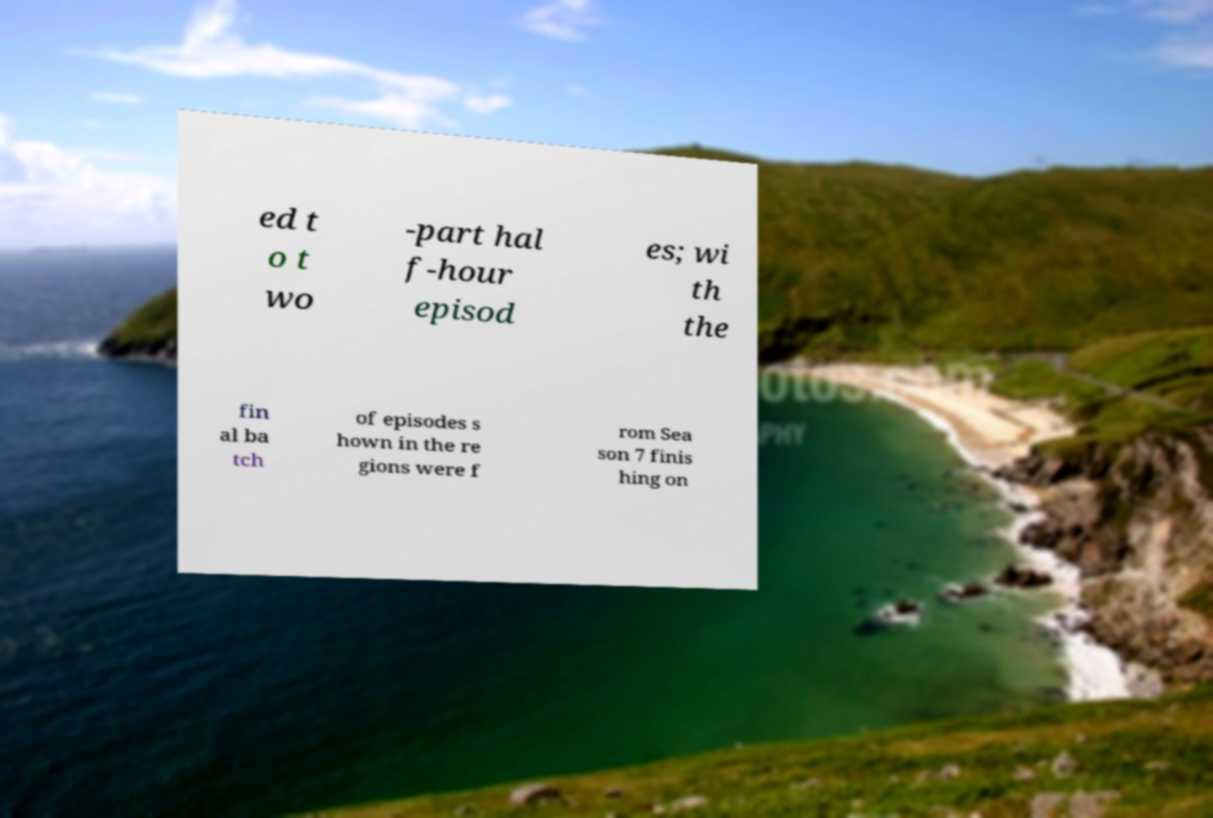There's text embedded in this image that I need extracted. Can you transcribe it verbatim? ed t o t wo -part hal f-hour episod es; wi th the fin al ba tch of episodes s hown in the re gions were f rom Sea son 7 finis hing on 